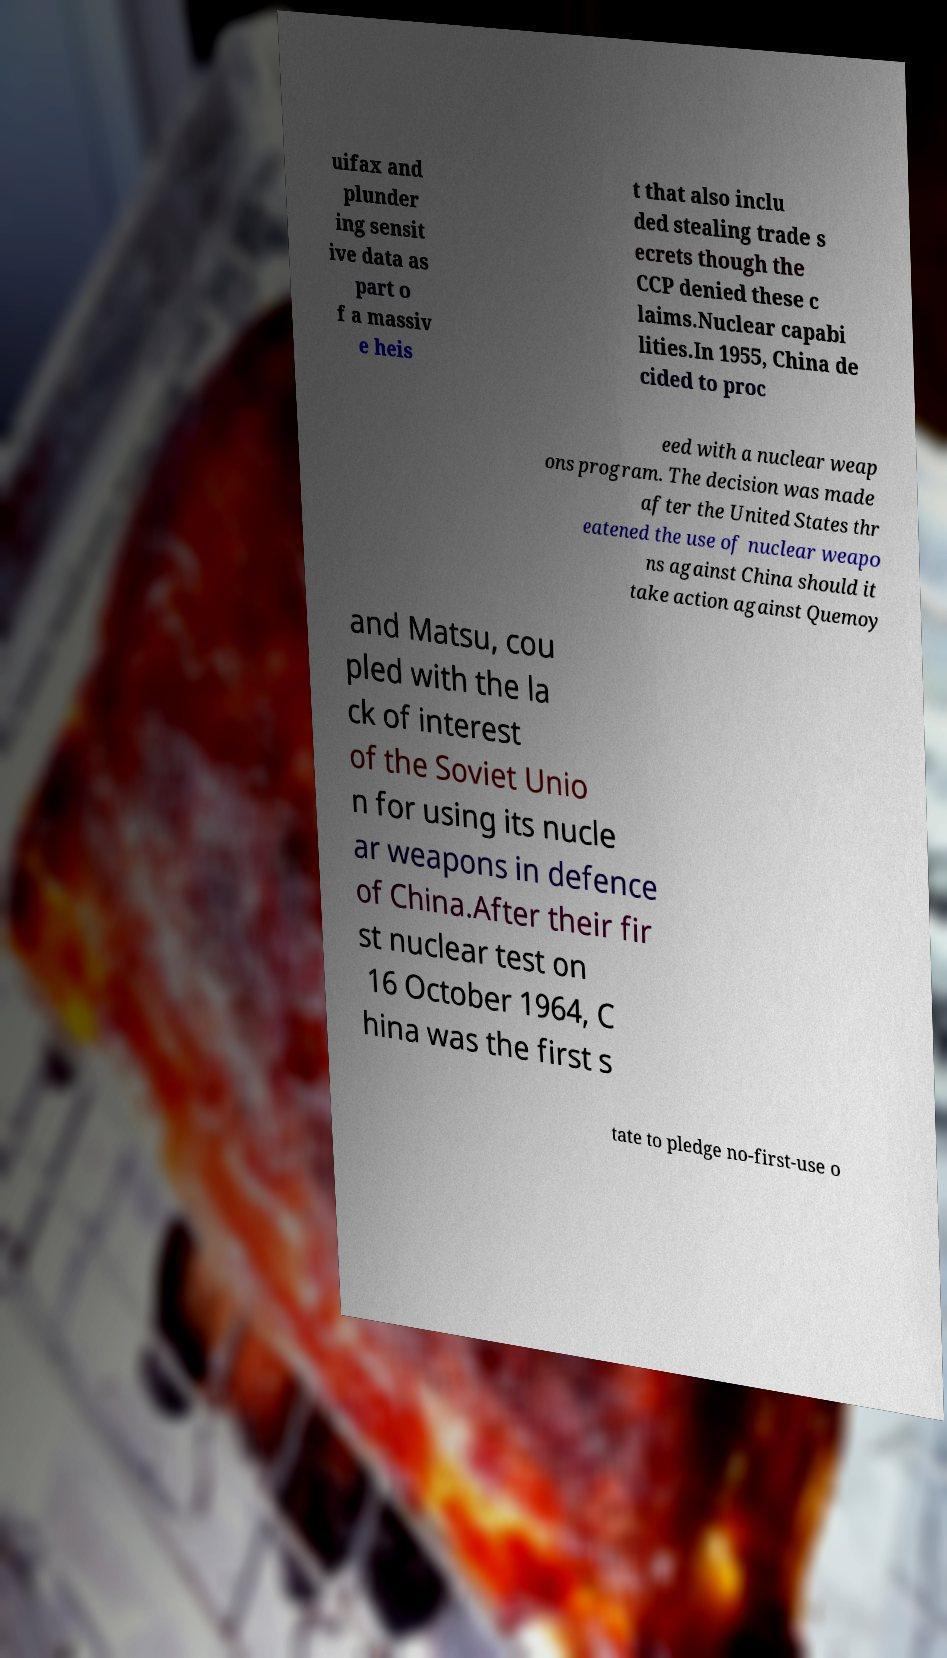Please identify and transcribe the text found in this image. uifax and plunder ing sensit ive data as part o f a massiv e heis t that also inclu ded stealing trade s ecrets though the CCP denied these c laims.Nuclear capabi lities.In 1955, China de cided to proc eed with a nuclear weap ons program. The decision was made after the United States thr eatened the use of nuclear weapo ns against China should it take action against Quemoy and Matsu, cou pled with the la ck of interest of the Soviet Unio n for using its nucle ar weapons in defence of China.After their fir st nuclear test on 16 October 1964, C hina was the first s tate to pledge no-first-use o 